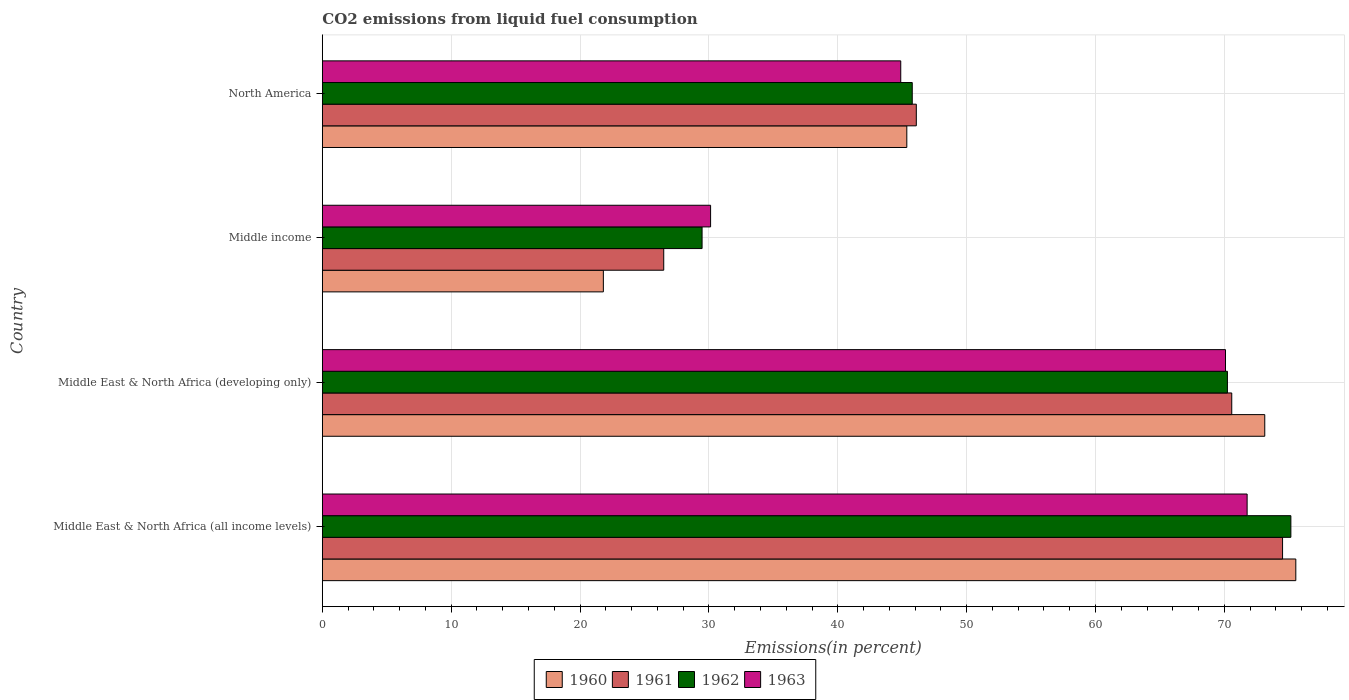How many different coloured bars are there?
Keep it short and to the point. 4. How many groups of bars are there?
Make the answer very short. 4. Are the number of bars per tick equal to the number of legend labels?
Ensure brevity in your answer.  Yes. Are the number of bars on each tick of the Y-axis equal?
Make the answer very short. Yes. What is the label of the 3rd group of bars from the top?
Make the answer very short. Middle East & North Africa (developing only). What is the total CO2 emitted in 1963 in North America?
Ensure brevity in your answer.  44.89. Across all countries, what is the maximum total CO2 emitted in 1962?
Your answer should be compact. 75.16. Across all countries, what is the minimum total CO2 emitted in 1960?
Offer a very short reply. 21.81. In which country was the total CO2 emitted in 1962 maximum?
Your response must be concise. Middle East & North Africa (all income levels). In which country was the total CO2 emitted in 1961 minimum?
Make the answer very short. Middle income. What is the total total CO2 emitted in 1963 in the graph?
Keep it short and to the point. 216.87. What is the difference between the total CO2 emitted in 1962 in Middle East & North Africa (all income levels) and that in Middle income?
Offer a terse response. 45.69. What is the difference between the total CO2 emitted in 1962 in Middle East & North Africa (all income levels) and the total CO2 emitted in 1960 in Middle income?
Keep it short and to the point. 53.35. What is the average total CO2 emitted in 1962 per country?
Offer a very short reply. 55.16. What is the difference between the total CO2 emitted in 1963 and total CO2 emitted in 1961 in Middle income?
Make the answer very short. 3.64. In how many countries, is the total CO2 emitted in 1962 greater than 70 %?
Offer a very short reply. 2. What is the ratio of the total CO2 emitted in 1961 in Middle East & North Africa (all income levels) to that in Middle East & North Africa (developing only)?
Ensure brevity in your answer.  1.06. Is the difference between the total CO2 emitted in 1963 in Middle income and North America greater than the difference between the total CO2 emitted in 1961 in Middle income and North America?
Your response must be concise. Yes. What is the difference between the highest and the second highest total CO2 emitted in 1960?
Ensure brevity in your answer.  2.41. What is the difference between the highest and the lowest total CO2 emitted in 1962?
Your answer should be compact. 45.69. In how many countries, is the total CO2 emitted in 1963 greater than the average total CO2 emitted in 1963 taken over all countries?
Provide a short and direct response. 2. Is it the case that in every country, the sum of the total CO2 emitted in 1963 and total CO2 emitted in 1962 is greater than the sum of total CO2 emitted in 1960 and total CO2 emitted in 1961?
Offer a very short reply. No. Is it the case that in every country, the sum of the total CO2 emitted in 1962 and total CO2 emitted in 1963 is greater than the total CO2 emitted in 1961?
Your answer should be compact. Yes. How many bars are there?
Give a very brief answer. 16. How many countries are there in the graph?
Make the answer very short. 4. Does the graph contain any zero values?
Ensure brevity in your answer.  No. Where does the legend appear in the graph?
Your answer should be compact. Bottom center. How are the legend labels stacked?
Give a very brief answer. Horizontal. What is the title of the graph?
Your answer should be very brief. CO2 emissions from liquid fuel consumption. What is the label or title of the X-axis?
Provide a succinct answer. Emissions(in percent). What is the label or title of the Y-axis?
Offer a terse response. Country. What is the Emissions(in percent) of 1960 in Middle East & North Africa (all income levels)?
Your answer should be very brief. 75.54. What is the Emissions(in percent) of 1961 in Middle East & North Africa (all income levels)?
Keep it short and to the point. 74.51. What is the Emissions(in percent) of 1962 in Middle East & North Africa (all income levels)?
Your response must be concise. 75.16. What is the Emissions(in percent) of 1963 in Middle East & North Africa (all income levels)?
Your answer should be compact. 71.76. What is the Emissions(in percent) of 1960 in Middle East & North Africa (developing only)?
Make the answer very short. 73.13. What is the Emissions(in percent) of 1961 in Middle East & North Africa (developing only)?
Your answer should be very brief. 70.57. What is the Emissions(in percent) in 1962 in Middle East & North Africa (developing only)?
Give a very brief answer. 70.23. What is the Emissions(in percent) in 1963 in Middle East & North Africa (developing only)?
Give a very brief answer. 70.09. What is the Emissions(in percent) in 1960 in Middle income?
Provide a short and direct response. 21.81. What is the Emissions(in percent) in 1961 in Middle income?
Your answer should be compact. 26.49. What is the Emissions(in percent) in 1962 in Middle income?
Ensure brevity in your answer.  29.47. What is the Emissions(in percent) of 1963 in Middle income?
Your answer should be very brief. 30.13. What is the Emissions(in percent) in 1960 in North America?
Make the answer very short. 45.36. What is the Emissions(in percent) in 1961 in North America?
Provide a succinct answer. 46.09. What is the Emissions(in percent) in 1962 in North America?
Offer a terse response. 45.78. What is the Emissions(in percent) of 1963 in North America?
Keep it short and to the point. 44.89. Across all countries, what is the maximum Emissions(in percent) in 1960?
Ensure brevity in your answer.  75.54. Across all countries, what is the maximum Emissions(in percent) of 1961?
Make the answer very short. 74.51. Across all countries, what is the maximum Emissions(in percent) in 1962?
Provide a short and direct response. 75.16. Across all countries, what is the maximum Emissions(in percent) of 1963?
Give a very brief answer. 71.76. Across all countries, what is the minimum Emissions(in percent) in 1960?
Offer a very short reply. 21.81. Across all countries, what is the minimum Emissions(in percent) of 1961?
Your answer should be very brief. 26.49. Across all countries, what is the minimum Emissions(in percent) of 1962?
Your response must be concise. 29.47. Across all countries, what is the minimum Emissions(in percent) in 1963?
Your answer should be compact. 30.13. What is the total Emissions(in percent) of 1960 in the graph?
Offer a very short reply. 215.84. What is the total Emissions(in percent) in 1961 in the graph?
Ensure brevity in your answer.  217.67. What is the total Emissions(in percent) of 1962 in the graph?
Provide a succinct answer. 220.64. What is the total Emissions(in percent) of 1963 in the graph?
Provide a short and direct response. 216.87. What is the difference between the Emissions(in percent) of 1960 in Middle East & North Africa (all income levels) and that in Middle East & North Africa (developing only)?
Offer a terse response. 2.41. What is the difference between the Emissions(in percent) in 1961 in Middle East & North Africa (all income levels) and that in Middle East & North Africa (developing only)?
Make the answer very short. 3.94. What is the difference between the Emissions(in percent) of 1962 in Middle East & North Africa (all income levels) and that in Middle East & North Africa (developing only)?
Ensure brevity in your answer.  4.92. What is the difference between the Emissions(in percent) of 1963 in Middle East & North Africa (all income levels) and that in Middle East & North Africa (developing only)?
Your answer should be compact. 1.68. What is the difference between the Emissions(in percent) of 1960 in Middle East & North Africa (all income levels) and that in Middle income?
Provide a succinct answer. 53.73. What is the difference between the Emissions(in percent) of 1961 in Middle East & North Africa (all income levels) and that in Middle income?
Keep it short and to the point. 48.02. What is the difference between the Emissions(in percent) of 1962 in Middle East & North Africa (all income levels) and that in Middle income?
Give a very brief answer. 45.69. What is the difference between the Emissions(in percent) in 1963 in Middle East & North Africa (all income levels) and that in Middle income?
Provide a short and direct response. 41.63. What is the difference between the Emissions(in percent) of 1960 in Middle East & North Africa (all income levels) and that in North America?
Your answer should be compact. 30.19. What is the difference between the Emissions(in percent) of 1961 in Middle East & North Africa (all income levels) and that in North America?
Ensure brevity in your answer.  28.42. What is the difference between the Emissions(in percent) in 1962 in Middle East & North Africa (all income levels) and that in North America?
Provide a short and direct response. 29.38. What is the difference between the Emissions(in percent) in 1963 in Middle East & North Africa (all income levels) and that in North America?
Your answer should be very brief. 26.88. What is the difference between the Emissions(in percent) in 1960 in Middle East & North Africa (developing only) and that in Middle income?
Offer a terse response. 51.33. What is the difference between the Emissions(in percent) in 1961 in Middle East & North Africa (developing only) and that in Middle income?
Make the answer very short. 44.08. What is the difference between the Emissions(in percent) in 1962 in Middle East & North Africa (developing only) and that in Middle income?
Provide a succinct answer. 40.77. What is the difference between the Emissions(in percent) of 1963 in Middle East & North Africa (developing only) and that in Middle income?
Provide a succinct answer. 39.96. What is the difference between the Emissions(in percent) of 1960 in Middle East & North Africa (developing only) and that in North America?
Provide a short and direct response. 27.78. What is the difference between the Emissions(in percent) in 1961 in Middle East & North Africa (developing only) and that in North America?
Offer a very short reply. 24.48. What is the difference between the Emissions(in percent) of 1962 in Middle East & North Africa (developing only) and that in North America?
Give a very brief answer. 24.46. What is the difference between the Emissions(in percent) of 1963 in Middle East & North Africa (developing only) and that in North America?
Your response must be concise. 25.2. What is the difference between the Emissions(in percent) in 1960 in Middle income and that in North America?
Your response must be concise. -23.55. What is the difference between the Emissions(in percent) of 1961 in Middle income and that in North America?
Keep it short and to the point. -19.6. What is the difference between the Emissions(in percent) in 1962 in Middle income and that in North America?
Your answer should be compact. -16.31. What is the difference between the Emissions(in percent) of 1963 in Middle income and that in North America?
Ensure brevity in your answer.  -14.76. What is the difference between the Emissions(in percent) in 1960 in Middle East & North Africa (all income levels) and the Emissions(in percent) in 1961 in Middle East & North Africa (developing only)?
Your answer should be compact. 4.97. What is the difference between the Emissions(in percent) of 1960 in Middle East & North Africa (all income levels) and the Emissions(in percent) of 1962 in Middle East & North Africa (developing only)?
Ensure brevity in your answer.  5.31. What is the difference between the Emissions(in percent) in 1960 in Middle East & North Africa (all income levels) and the Emissions(in percent) in 1963 in Middle East & North Africa (developing only)?
Offer a terse response. 5.46. What is the difference between the Emissions(in percent) of 1961 in Middle East & North Africa (all income levels) and the Emissions(in percent) of 1962 in Middle East & North Africa (developing only)?
Provide a short and direct response. 4.28. What is the difference between the Emissions(in percent) in 1961 in Middle East & North Africa (all income levels) and the Emissions(in percent) in 1963 in Middle East & North Africa (developing only)?
Keep it short and to the point. 4.43. What is the difference between the Emissions(in percent) in 1962 in Middle East & North Africa (all income levels) and the Emissions(in percent) in 1963 in Middle East & North Africa (developing only)?
Keep it short and to the point. 5.07. What is the difference between the Emissions(in percent) in 1960 in Middle East & North Africa (all income levels) and the Emissions(in percent) in 1961 in Middle income?
Ensure brevity in your answer.  49.05. What is the difference between the Emissions(in percent) in 1960 in Middle East & North Africa (all income levels) and the Emissions(in percent) in 1962 in Middle income?
Provide a short and direct response. 46.07. What is the difference between the Emissions(in percent) of 1960 in Middle East & North Africa (all income levels) and the Emissions(in percent) of 1963 in Middle income?
Your response must be concise. 45.41. What is the difference between the Emissions(in percent) in 1961 in Middle East & North Africa (all income levels) and the Emissions(in percent) in 1962 in Middle income?
Your answer should be very brief. 45.05. What is the difference between the Emissions(in percent) in 1961 in Middle East & North Africa (all income levels) and the Emissions(in percent) in 1963 in Middle income?
Your answer should be compact. 44.38. What is the difference between the Emissions(in percent) in 1962 in Middle East & North Africa (all income levels) and the Emissions(in percent) in 1963 in Middle income?
Keep it short and to the point. 45.03. What is the difference between the Emissions(in percent) of 1960 in Middle East & North Africa (all income levels) and the Emissions(in percent) of 1961 in North America?
Make the answer very short. 29.45. What is the difference between the Emissions(in percent) of 1960 in Middle East & North Africa (all income levels) and the Emissions(in percent) of 1962 in North America?
Your answer should be compact. 29.77. What is the difference between the Emissions(in percent) of 1960 in Middle East & North Africa (all income levels) and the Emissions(in percent) of 1963 in North America?
Your response must be concise. 30.66. What is the difference between the Emissions(in percent) of 1961 in Middle East & North Africa (all income levels) and the Emissions(in percent) of 1962 in North America?
Your response must be concise. 28.74. What is the difference between the Emissions(in percent) of 1961 in Middle East & North Africa (all income levels) and the Emissions(in percent) of 1963 in North America?
Offer a terse response. 29.63. What is the difference between the Emissions(in percent) of 1962 in Middle East & North Africa (all income levels) and the Emissions(in percent) of 1963 in North America?
Your answer should be very brief. 30.27. What is the difference between the Emissions(in percent) of 1960 in Middle East & North Africa (developing only) and the Emissions(in percent) of 1961 in Middle income?
Keep it short and to the point. 46.64. What is the difference between the Emissions(in percent) in 1960 in Middle East & North Africa (developing only) and the Emissions(in percent) in 1962 in Middle income?
Make the answer very short. 43.66. What is the difference between the Emissions(in percent) in 1960 in Middle East & North Africa (developing only) and the Emissions(in percent) in 1963 in Middle income?
Provide a succinct answer. 43. What is the difference between the Emissions(in percent) in 1961 in Middle East & North Africa (developing only) and the Emissions(in percent) in 1962 in Middle income?
Ensure brevity in your answer.  41.1. What is the difference between the Emissions(in percent) in 1961 in Middle East & North Africa (developing only) and the Emissions(in percent) in 1963 in Middle income?
Your answer should be very brief. 40.44. What is the difference between the Emissions(in percent) in 1962 in Middle East & North Africa (developing only) and the Emissions(in percent) in 1963 in Middle income?
Ensure brevity in your answer.  40.11. What is the difference between the Emissions(in percent) in 1960 in Middle East & North Africa (developing only) and the Emissions(in percent) in 1961 in North America?
Provide a short and direct response. 27.04. What is the difference between the Emissions(in percent) in 1960 in Middle East & North Africa (developing only) and the Emissions(in percent) in 1962 in North America?
Give a very brief answer. 27.36. What is the difference between the Emissions(in percent) of 1960 in Middle East & North Africa (developing only) and the Emissions(in percent) of 1963 in North America?
Your answer should be compact. 28.25. What is the difference between the Emissions(in percent) in 1961 in Middle East & North Africa (developing only) and the Emissions(in percent) in 1962 in North America?
Give a very brief answer. 24.79. What is the difference between the Emissions(in percent) of 1961 in Middle East & North Africa (developing only) and the Emissions(in percent) of 1963 in North America?
Offer a terse response. 25.69. What is the difference between the Emissions(in percent) of 1962 in Middle East & North Africa (developing only) and the Emissions(in percent) of 1963 in North America?
Provide a succinct answer. 25.35. What is the difference between the Emissions(in percent) of 1960 in Middle income and the Emissions(in percent) of 1961 in North America?
Offer a very short reply. -24.29. What is the difference between the Emissions(in percent) of 1960 in Middle income and the Emissions(in percent) of 1962 in North America?
Provide a short and direct response. -23.97. What is the difference between the Emissions(in percent) in 1960 in Middle income and the Emissions(in percent) in 1963 in North America?
Your response must be concise. -23.08. What is the difference between the Emissions(in percent) of 1961 in Middle income and the Emissions(in percent) of 1962 in North America?
Provide a short and direct response. -19.29. What is the difference between the Emissions(in percent) in 1961 in Middle income and the Emissions(in percent) in 1963 in North America?
Your answer should be very brief. -18.39. What is the difference between the Emissions(in percent) in 1962 in Middle income and the Emissions(in percent) in 1963 in North America?
Your answer should be very brief. -15.42. What is the average Emissions(in percent) in 1960 per country?
Provide a short and direct response. 53.96. What is the average Emissions(in percent) of 1961 per country?
Your response must be concise. 54.42. What is the average Emissions(in percent) of 1962 per country?
Make the answer very short. 55.16. What is the average Emissions(in percent) of 1963 per country?
Give a very brief answer. 54.22. What is the difference between the Emissions(in percent) of 1960 and Emissions(in percent) of 1961 in Middle East & North Africa (all income levels)?
Offer a terse response. 1.03. What is the difference between the Emissions(in percent) of 1960 and Emissions(in percent) of 1962 in Middle East & North Africa (all income levels)?
Your answer should be compact. 0.38. What is the difference between the Emissions(in percent) in 1960 and Emissions(in percent) in 1963 in Middle East & North Africa (all income levels)?
Provide a short and direct response. 3.78. What is the difference between the Emissions(in percent) of 1961 and Emissions(in percent) of 1962 in Middle East & North Africa (all income levels)?
Offer a terse response. -0.65. What is the difference between the Emissions(in percent) in 1961 and Emissions(in percent) in 1963 in Middle East & North Africa (all income levels)?
Your answer should be very brief. 2.75. What is the difference between the Emissions(in percent) in 1962 and Emissions(in percent) in 1963 in Middle East & North Africa (all income levels)?
Give a very brief answer. 3.4. What is the difference between the Emissions(in percent) of 1960 and Emissions(in percent) of 1961 in Middle East & North Africa (developing only)?
Your answer should be very brief. 2.56. What is the difference between the Emissions(in percent) in 1960 and Emissions(in percent) in 1962 in Middle East & North Africa (developing only)?
Make the answer very short. 2.9. What is the difference between the Emissions(in percent) of 1960 and Emissions(in percent) of 1963 in Middle East & North Africa (developing only)?
Provide a short and direct response. 3.05. What is the difference between the Emissions(in percent) of 1961 and Emissions(in percent) of 1962 in Middle East & North Africa (developing only)?
Make the answer very short. 0.34. What is the difference between the Emissions(in percent) of 1961 and Emissions(in percent) of 1963 in Middle East & North Africa (developing only)?
Offer a very short reply. 0.48. What is the difference between the Emissions(in percent) of 1962 and Emissions(in percent) of 1963 in Middle East & North Africa (developing only)?
Make the answer very short. 0.15. What is the difference between the Emissions(in percent) in 1960 and Emissions(in percent) in 1961 in Middle income?
Keep it short and to the point. -4.68. What is the difference between the Emissions(in percent) in 1960 and Emissions(in percent) in 1962 in Middle income?
Your answer should be very brief. -7.66. What is the difference between the Emissions(in percent) of 1960 and Emissions(in percent) of 1963 in Middle income?
Ensure brevity in your answer.  -8.32. What is the difference between the Emissions(in percent) of 1961 and Emissions(in percent) of 1962 in Middle income?
Ensure brevity in your answer.  -2.98. What is the difference between the Emissions(in percent) in 1961 and Emissions(in percent) in 1963 in Middle income?
Offer a very short reply. -3.64. What is the difference between the Emissions(in percent) in 1962 and Emissions(in percent) in 1963 in Middle income?
Keep it short and to the point. -0.66. What is the difference between the Emissions(in percent) of 1960 and Emissions(in percent) of 1961 in North America?
Your answer should be compact. -0.74. What is the difference between the Emissions(in percent) of 1960 and Emissions(in percent) of 1962 in North America?
Keep it short and to the point. -0.42. What is the difference between the Emissions(in percent) of 1960 and Emissions(in percent) of 1963 in North America?
Your answer should be compact. 0.47. What is the difference between the Emissions(in percent) in 1961 and Emissions(in percent) in 1962 in North America?
Provide a succinct answer. 0.32. What is the difference between the Emissions(in percent) of 1961 and Emissions(in percent) of 1963 in North America?
Keep it short and to the point. 1.21. What is the difference between the Emissions(in percent) in 1962 and Emissions(in percent) in 1963 in North America?
Keep it short and to the point. 0.89. What is the ratio of the Emissions(in percent) of 1960 in Middle East & North Africa (all income levels) to that in Middle East & North Africa (developing only)?
Provide a succinct answer. 1.03. What is the ratio of the Emissions(in percent) in 1961 in Middle East & North Africa (all income levels) to that in Middle East & North Africa (developing only)?
Offer a very short reply. 1.06. What is the ratio of the Emissions(in percent) of 1962 in Middle East & North Africa (all income levels) to that in Middle East & North Africa (developing only)?
Make the answer very short. 1.07. What is the ratio of the Emissions(in percent) of 1963 in Middle East & North Africa (all income levels) to that in Middle East & North Africa (developing only)?
Your response must be concise. 1.02. What is the ratio of the Emissions(in percent) in 1960 in Middle East & North Africa (all income levels) to that in Middle income?
Provide a short and direct response. 3.46. What is the ratio of the Emissions(in percent) in 1961 in Middle East & North Africa (all income levels) to that in Middle income?
Ensure brevity in your answer.  2.81. What is the ratio of the Emissions(in percent) of 1962 in Middle East & North Africa (all income levels) to that in Middle income?
Your answer should be compact. 2.55. What is the ratio of the Emissions(in percent) in 1963 in Middle East & North Africa (all income levels) to that in Middle income?
Your answer should be very brief. 2.38. What is the ratio of the Emissions(in percent) of 1960 in Middle East & North Africa (all income levels) to that in North America?
Your answer should be very brief. 1.67. What is the ratio of the Emissions(in percent) in 1961 in Middle East & North Africa (all income levels) to that in North America?
Provide a succinct answer. 1.62. What is the ratio of the Emissions(in percent) of 1962 in Middle East & North Africa (all income levels) to that in North America?
Make the answer very short. 1.64. What is the ratio of the Emissions(in percent) of 1963 in Middle East & North Africa (all income levels) to that in North America?
Provide a short and direct response. 1.6. What is the ratio of the Emissions(in percent) in 1960 in Middle East & North Africa (developing only) to that in Middle income?
Offer a very short reply. 3.35. What is the ratio of the Emissions(in percent) of 1961 in Middle East & North Africa (developing only) to that in Middle income?
Your answer should be compact. 2.66. What is the ratio of the Emissions(in percent) of 1962 in Middle East & North Africa (developing only) to that in Middle income?
Your response must be concise. 2.38. What is the ratio of the Emissions(in percent) in 1963 in Middle East & North Africa (developing only) to that in Middle income?
Make the answer very short. 2.33. What is the ratio of the Emissions(in percent) in 1960 in Middle East & North Africa (developing only) to that in North America?
Make the answer very short. 1.61. What is the ratio of the Emissions(in percent) of 1961 in Middle East & North Africa (developing only) to that in North America?
Your answer should be very brief. 1.53. What is the ratio of the Emissions(in percent) of 1962 in Middle East & North Africa (developing only) to that in North America?
Your answer should be very brief. 1.53. What is the ratio of the Emissions(in percent) in 1963 in Middle East & North Africa (developing only) to that in North America?
Offer a terse response. 1.56. What is the ratio of the Emissions(in percent) of 1960 in Middle income to that in North America?
Your answer should be very brief. 0.48. What is the ratio of the Emissions(in percent) in 1961 in Middle income to that in North America?
Make the answer very short. 0.57. What is the ratio of the Emissions(in percent) of 1962 in Middle income to that in North America?
Give a very brief answer. 0.64. What is the ratio of the Emissions(in percent) in 1963 in Middle income to that in North America?
Provide a succinct answer. 0.67. What is the difference between the highest and the second highest Emissions(in percent) of 1960?
Your response must be concise. 2.41. What is the difference between the highest and the second highest Emissions(in percent) in 1961?
Give a very brief answer. 3.94. What is the difference between the highest and the second highest Emissions(in percent) of 1962?
Keep it short and to the point. 4.92. What is the difference between the highest and the second highest Emissions(in percent) in 1963?
Provide a short and direct response. 1.68. What is the difference between the highest and the lowest Emissions(in percent) of 1960?
Give a very brief answer. 53.73. What is the difference between the highest and the lowest Emissions(in percent) of 1961?
Ensure brevity in your answer.  48.02. What is the difference between the highest and the lowest Emissions(in percent) of 1962?
Give a very brief answer. 45.69. What is the difference between the highest and the lowest Emissions(in percent) in 1963?
Ensure brevity in your answer.  41.63. 